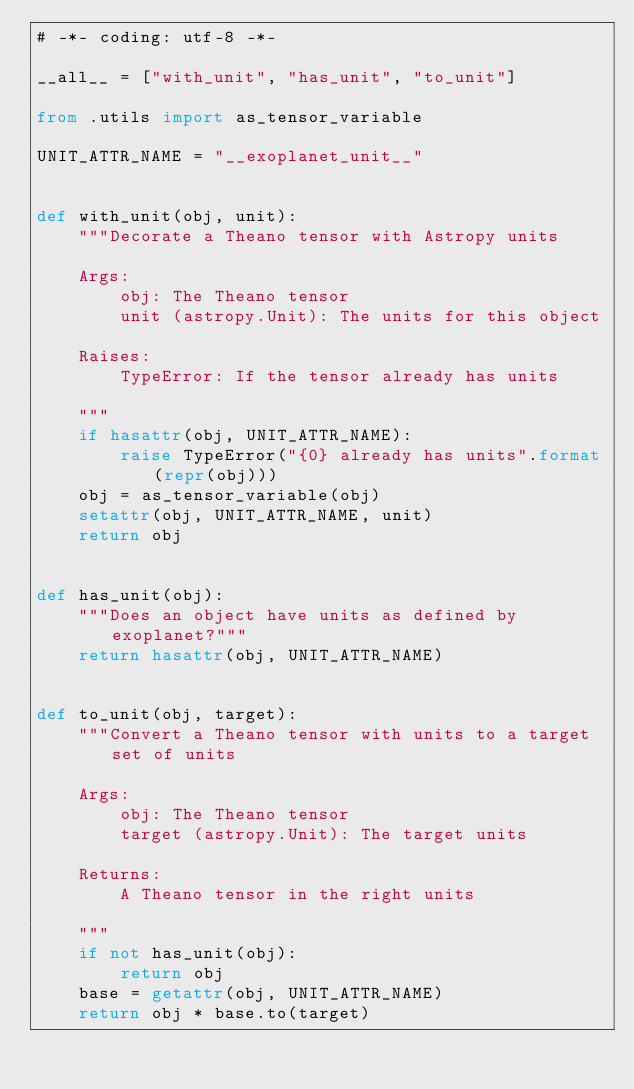<code> <loc_0><loc_0><loc_500><loc_500><_Python_># -*- coding: utf-8 -*-

__all__ = ["with_unit", "has_unit", "to_unit"]

from .utils import as_tensor_variable

UNIT_ATTR_NAME = "__exoplanet_unit__"


def with_unit(obj, unit):
    """Decorate a Theano tensor with Astropy units

    Args:
        obj: The Theano tensor
        unit (astropy.Unit): The units for this object

    Raises:
        TypeError: If the tensor already has units

    """
    if hasattr(obj, UNIT_ATTR_NAME):
        raise TypeError("{0} already has units".format(repr(obj)))
    obj = as_tensor_variable(obj)
    setattr(obj, UNIT_ATTR_NAME, unit)
    return obj


def has_unit(obj):
    """Does an object have units as defined by exoplanet?"""
    return hasattr(obj, UNIT_ATTR_NAME)


def to_unit(obj, target):
    """Convert a Theano tensor with units to a target set of units

    Args:
        obj: The Theano tensor
        target (astropy.Unit): The target units

    Returns:
        A Theano tensor in the right units

    """
    if not has_unit(obj):
        return obj
    base = getattr(obj, UNIT_ATTR_NAME)
    return obj * base.to(target)
</code> 